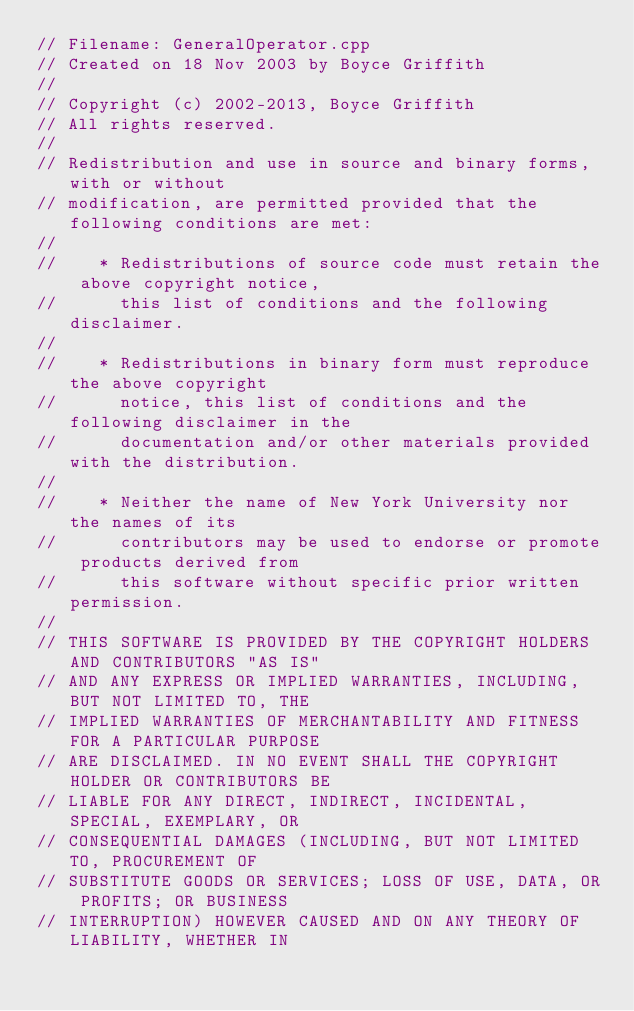<code> <loc_0><loc_0><loc_500><loc_500><_C++_>// Filename: GeneralOperator.cpp
// Created on 18 Nov 2003 by Boyce Griffith
//
// Copyright (c) 2002-2013, Boyce Griffith
// All rights reserved.
//
// Redistribution and use in source and binary forms, with or without
// modification, are permitted provided that the following conditions are met:
//
//    * Redistributions of source code must retain the above copyright notice,
//      this list of conditions and the following disclaimer.
//
//    * Redistributions in binary form must reproduce the above copyright
//      notice, this list of conditions and the following disclaimer in the
//      documentation and/or other materials provided with the distribution.
//
//    * Neither the name of New York University nor the names of its
//      contributors may be used to endorse or promote products derived from
//      this software without specific prior written permission.
//
// THIS SOFTWARE IS PROVIDED BY THE COPYRIGHT HOLDERS AND CONTRIBUTORS "AS IS"
// AND ANY EXPRESS OR IMPLIED WARRANTIES, INCLUDING, BUT NOT LIMITED TO, THE
// IMPLIED WARRANTIES OF MERCHANTABILITY AND FITNESS FOR A PARTICULAR PURPOSE
// ARE DISCLAIMED. IN NO EVENT SHALL THE COPYRIGHT HOLDER OR CONTRIBUTORS BE
// LIABLE FOR ANY DIRECT, INDIRECT, INCIDENTAL, SPECIAL, EXEMPLARY, OR
// CONSEQUENTIAL DAMAGES (INCLUDING, BUT NOT LIMITED TO, PROCUREMENT OF
// SUBSTITUTE GOODS OR SERVICES; LOSS OF USE, DATA, OR PROFITS; OR BUSINESS
// INTERRUPTION) HOWEVER CAUSED AND ON ANY THEORY OF LIABILITY, WHETHER IN</code> 